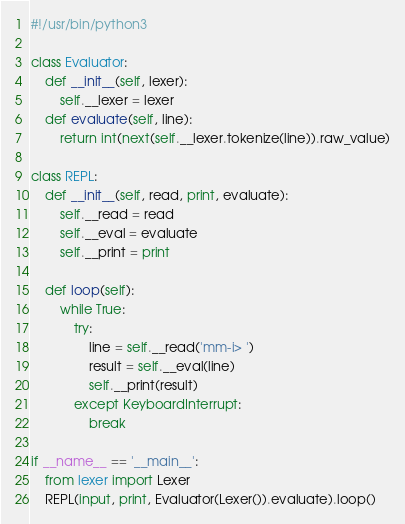Convert code to text. <code><loc_0><loc_0><loc_500><loc_500><_Python_>#!/usr/bin/python3

class Evaluator:
    def __init__(self, lexer):
        self.__lexer = lexer
    def evaluate(self, line):
        return int(next(self.__lexer.tokenize(line)).raw_value)

class REPL:
    def __init__(self, read, print, evaluate):
        self.__read = read
        self.__eval = evaluate
        self.__print = print

    def loop(self):
        while True:
            try:
                line = self.__read('mm-i> ')
                result = self.__eval(line)
                self.__print(result)
            except KeyboardInterrupt:
                break

if __name__ == '__main__':
    from lexer import Lexer
    REPL(input, print, Evaluator(Lexer()).evaluate).loop()
</code> 